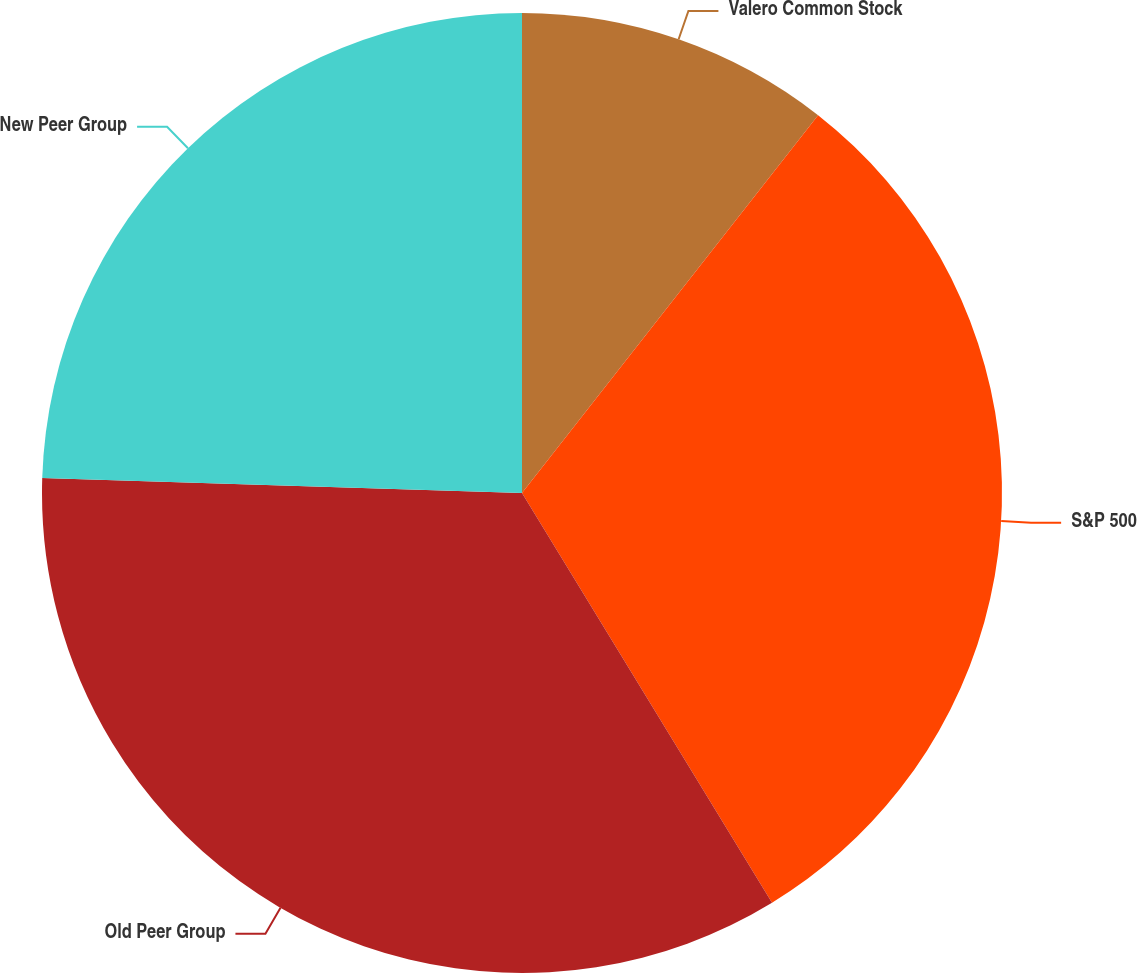Convert chart to OTSL. <chart><loc_0><loc_0><loc_500><loc_500><pie_chart><fcel>Valero Common Stock<fcel>S&P 500<fcel>Old Peer Group<fcel>New Peer Group<nl><fcel>10.58%<fcel>30.7%<fcel>34.22%<fcel>24.5%<nl></chart> 